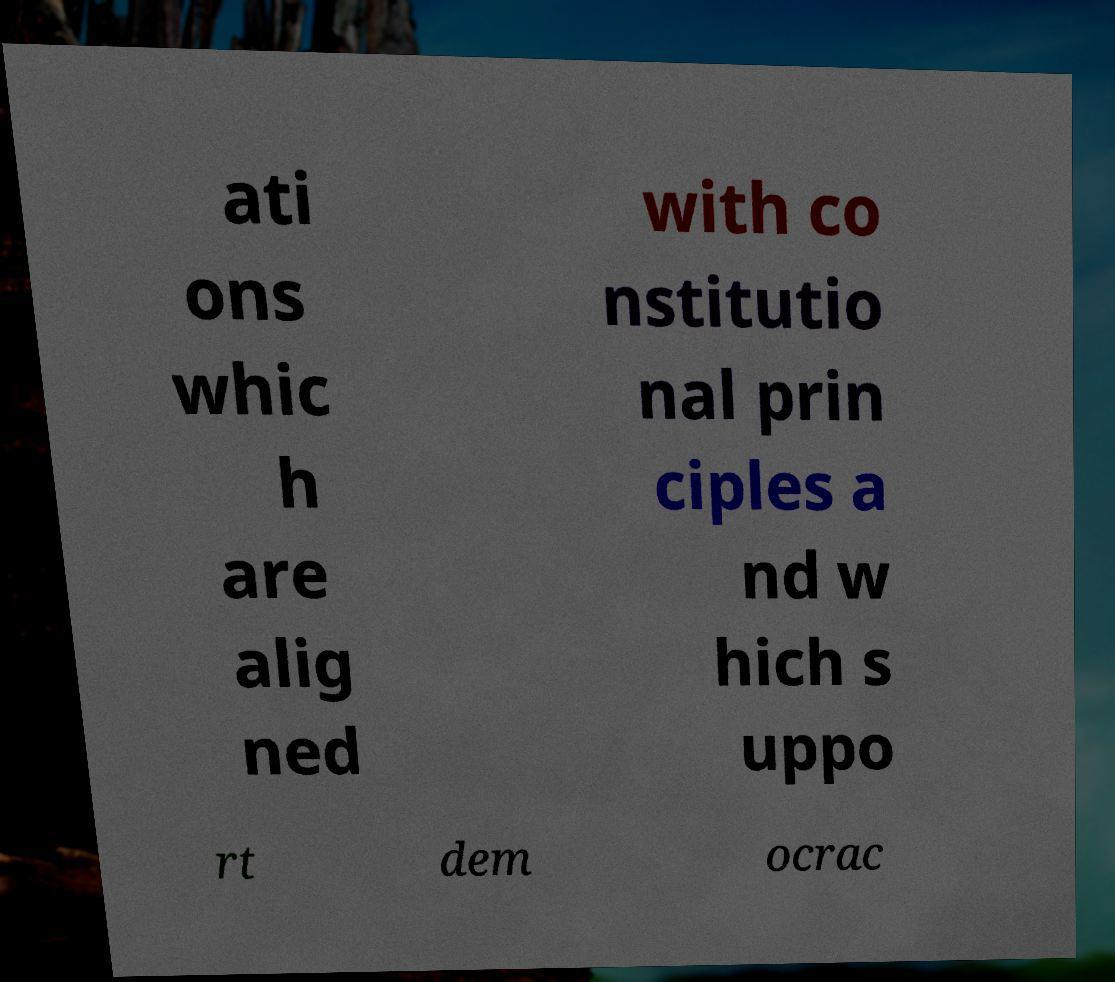I need the written content from this picture converted into text. Can you do that? ati ons whic h are alig ned with co nstitutio nal prin ciples a nd w hich s uppo rt dem ocrac 